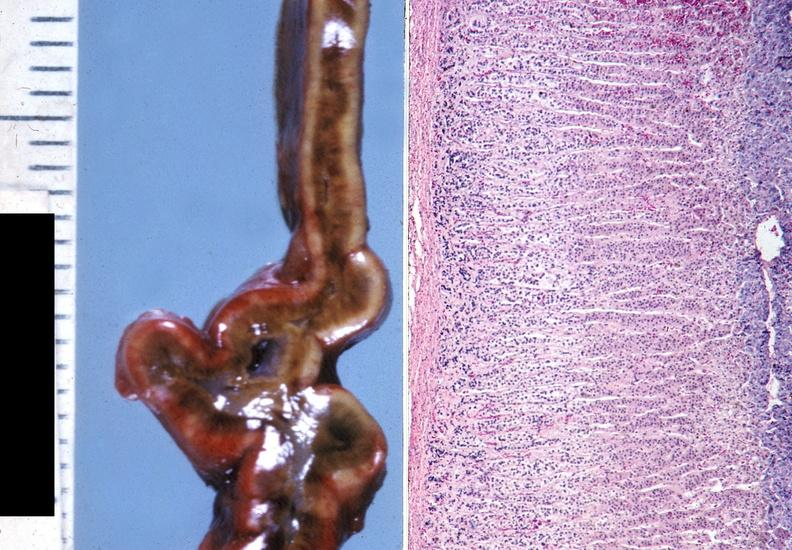does this image show adrenal, cushing syndrome?
Answer the question using a single word or phrase. Yes 